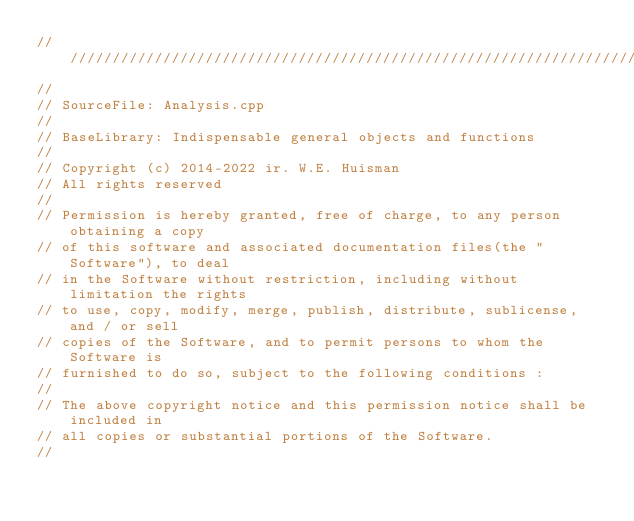Convert code to text. <code><loc_0><loc_0><loc_500><loc_500><_C++_>/////////////////////////////////////////////////////////////////////////////////
//
// SourceFile: Analysis.cpp
//
// BaseLibrary: Indispensable general objects and functions
// 
// Copyright (c) 2014-2022 ir. W.E. Huisman
// All rights reserved
//
// Permission is hereby granted, free of charge, to any person obtaining a copy
// of this software and associated documentation files(the "Software"), to deal
// in the Software without restriction, including without limitation the rights
// to use, copy, modify, merge, publish, distribute, sublicense, and / or sell
// copies of the Software, and to permit persons to whom the Software is
// furnished to do so, subject to the following conditions :
//
// The above copyright notice and this permission notice shall be included in
// all copies or substantial portions of the Software.
//</code> 